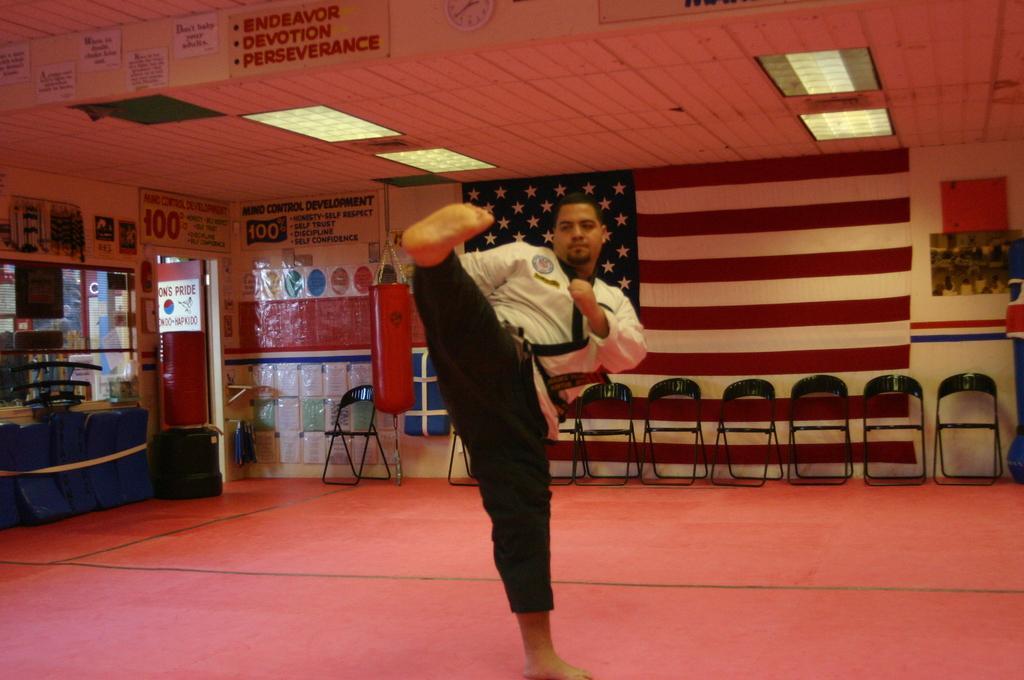Please provide a concise description of this image. In this image I can see the person wearing the white and black color dress. In the background I can see many chairs. I can also see many boards and banners to the wall. To the left I can see the blue color objects. I can see the lights and few more boards and clock on the top. 